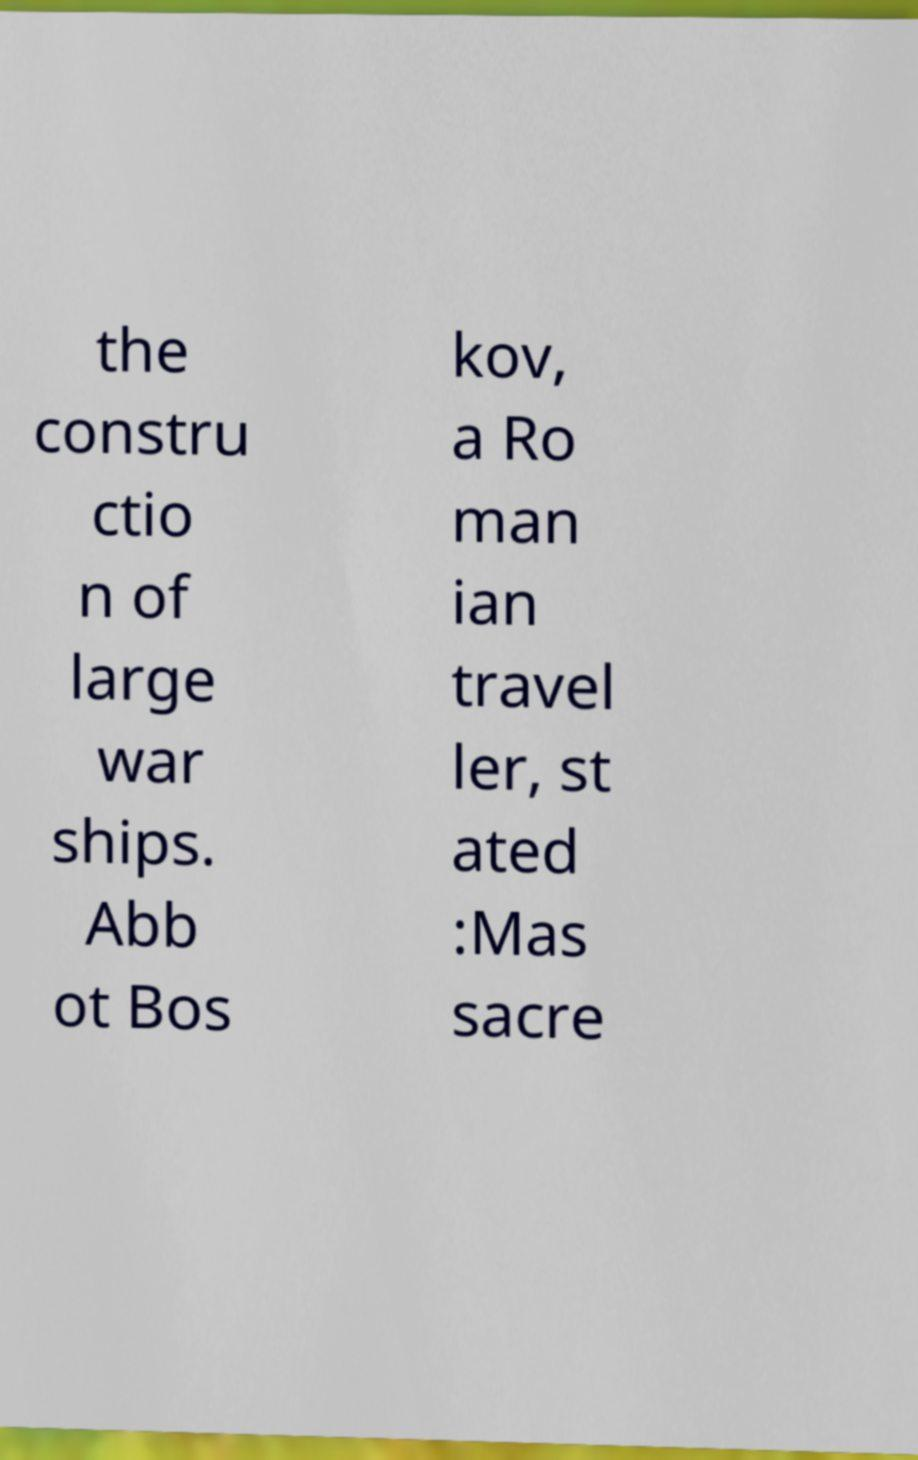Please read and relay the text visible in this image. What does it say? the constru ctio n of large war ships. Abb ot Bos kov, a Ro man ian travel ler, st ated :Mas sacre 